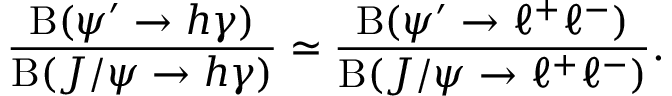<formula> <loc_0><loc_0><loc_500><loc_500>\frac { B ( \psi ^ { \prime } \to h \gamma ) } { B ( J / \psi \to h \gamma ) } \simeq \frac { B ( \psi ^ { \prime } \to \ell ^ { + } \ell ^ { - } ) } { B ( J / \psi \to \ell ^ { + } \ell ^ { - } ) } .</formula> 